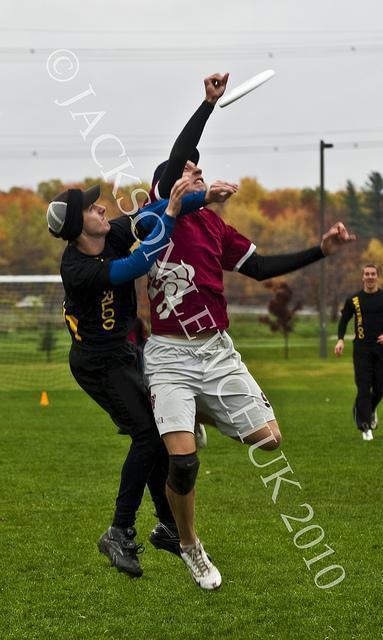What might stop you from using this image in a commercial capacity?
From the following four choices, select the correct answer to address the question.
Options: Disturbing nature, sexual nature, watermark, offensive nature. Watermark. 